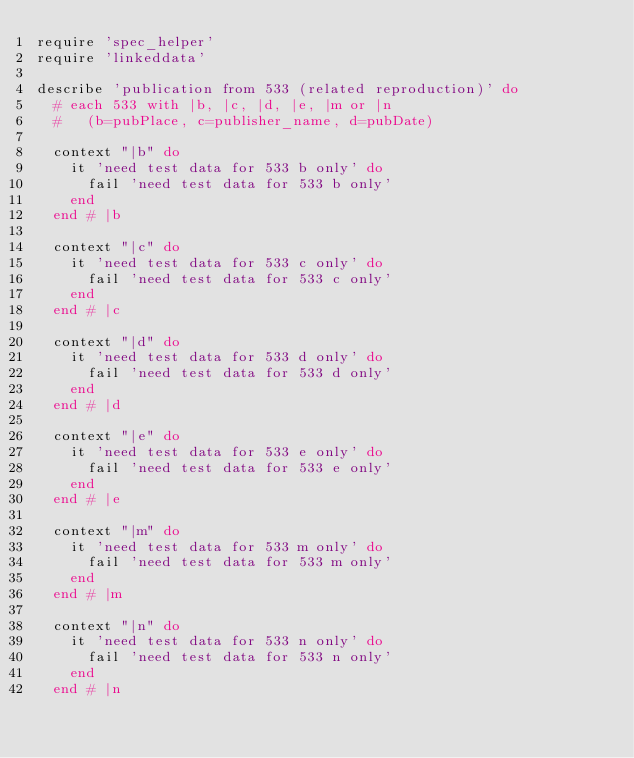Convert code to text. <code><loc_0><loc_0><loc_500><loc_500><_Ruby_>require 'spec_helper'
require 'linkeddata'

describe 'publication from 533 (related reproduction)' do
  # each 533 with |b, |c, |d, |e, |m or |n
  #   (b=pubPlace, c=publisher_name, d=pubDate)

  context "|b" do
    it 'need test data for 533 b only' do
      fail 'need test data for 533 b only'
    end
  end # |b

  context "|c" do
    it 'need test data for 533 c only' do
      fail 'need test data for 533 c only'
    end
  end # |c

  context "|d" do
    it 'need test data for 533 d only' do
      fail 'need test data for 533 d only'
    end
  end # |d

  context "|e" do
    it 'need test data for 533 e only' do
      fail 'need test data for 533 e only'
    end
  end # |e

  context "|m" do
    it 'need test data for 533 m only' do
      fail 'need test data for 533 m only'
    end
  end # |m

  context "|n" do
    it 'need test data for 533 n only' do
      fail 'need test data for 533 n only'
    end
  end # |n
</code> 